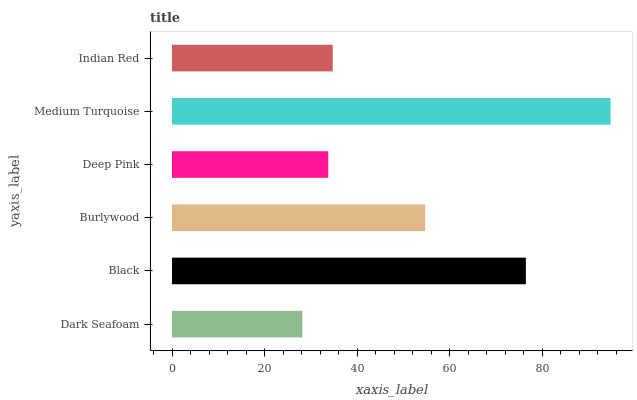Is Dark Seafoam the minimum?
Answer yes or no. Yes. Is Medium Turquoise the maximum?
Answer yes or no. Yes. Is Black the minimum?
Answer yes or no. No. Is Black the maximum?
Answer yes or no. No. Is Black greater than Dark Seafoam?
Answer yes or no. Yes. Is Dark Seafoam less than Black?
Answer yes or no. Yes. Is Dark Seafoam greater than Black?
Answer yes or no. No. Is Black less than Dark Seafoam?
Answer yes or no. No. Is Burlywood the high median?
Answer yes or no. Yes. Is Indian Red the low median?
Answer yes or no. Yes. Is Deep Pink the high median?
Answer yes or no. No. Is Deep Pink the low median?
Answer yes or no. No. 